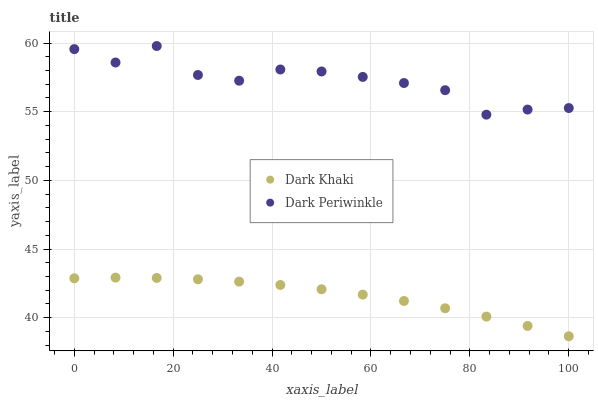Does Dark Khaki have the minimum area under the curve?
Answer yes or no. Yes. Does Dark Periwinkle have the maximum area under the curve?
Answer yes or no. Yes. Does Dark Periwinkle have the minimum area under the curve?
Answer yes or no. No. Is Dark Khaki the smoothest?
Answer yes or no. Yes. Is Dark Periwinkle the roughest?
Answer yes or no. Yes. Is Dark Periwinkle the smoothest?
Answer yes or no. No. Does Dark Khaki have the lowest value?
Answer yes or no. Yes. Does Dark Periwinkle have the lowest value?
Answer yes or no. No. Does Dark Periwinkle have the highest value?
Answer yes or no. Yes. Is Dark Khaki less than Dark Periwinkle?
Answer yes or no. Yes. Is Dark Periwinkle greater than Dark Khaki?
Answer yes or no. Yes. Does Dark Khaki intersect Dark Periwinkle?
Answer yes or no. No. 